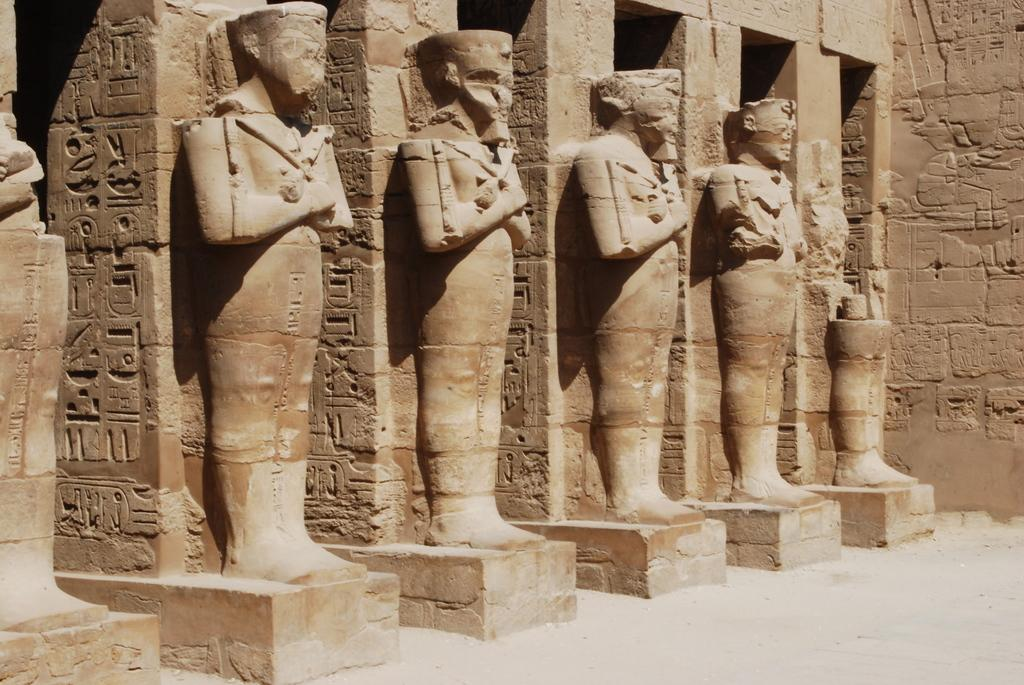What architectural features can be seen in the image? There are pillars in the image. What is on the pillars? There are sculptures on the pillars. What can be seen in the background of the image? There is a wall in the background of the image. How many snails can be seen crawling on the sculptures in the image? There are no snails present in the image; the sculptures are on the pillars. 